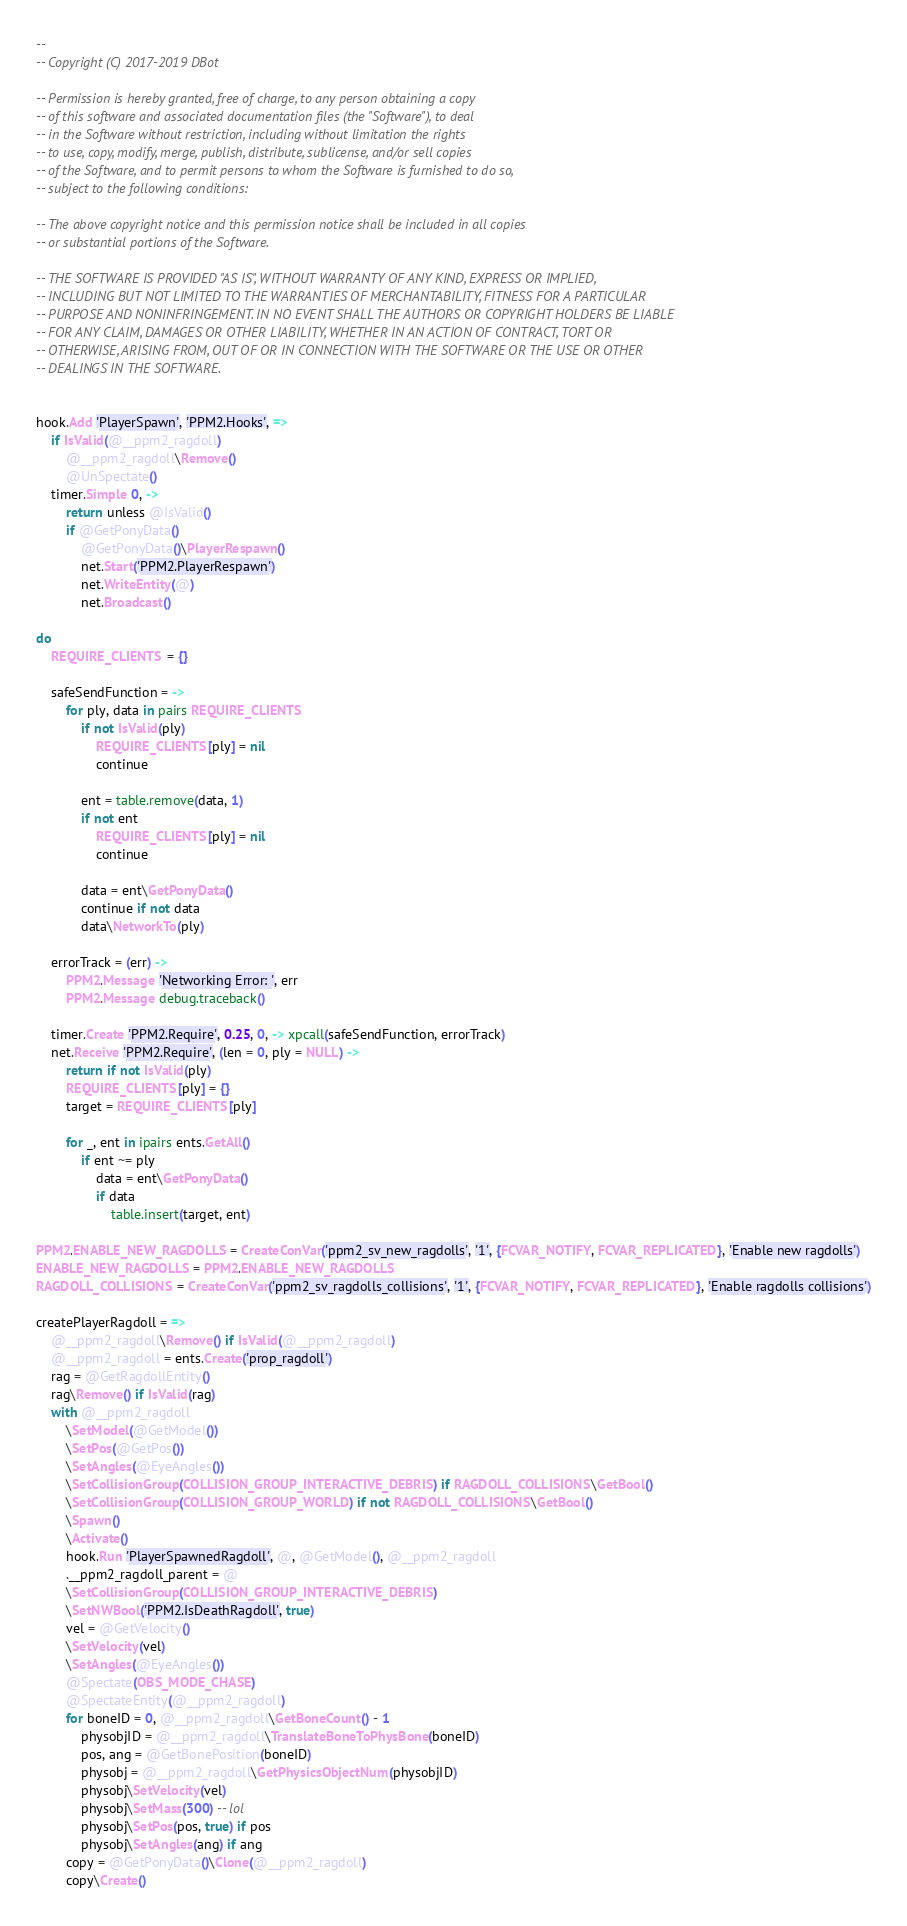<code> <loc_0><loc_0><loc_500><loc_500><_MoonScript_>
--
-- Copyright (C) 2017-2019 DBot

-- Permission is hereby granted, free of charge, to any person obtaining a copy
-- of this software and associated documentation files (the "Software"), to deal
-- in the Software without restriction, including without limitation the rights
-- to use, copy, modify, merge, publish, distribute, sublicense, and/or sell copies
-- of the Software, and to permit persons to whom the Software is furnished to do so,
-- subject to the following conditions:

-- The above copyright notice and this permission notice shall be included in all copies
-- or substantial portions of the Software.

-- THE SOFTWARE IS PROVIDED "AS IS", WITHOUT WARRANTY OF ANY KIND, EXPRESS OR IMPLIED,
-- INCLUDING BUT NOT LIMITED TO THE WARRANTIES OF MERCHANTABILITY, FITNESS FOR A PARTICULAR
-- PURPOSE AND NONINFRINGEMENT. IN NO EVENT SHALL THE AUTHORS OR COPYRIGHT HOLDERS BE LIABLE
-- FOR ANY CLAIM, DAMAGES OR OTHER LIABILITY, WHETHER IN AN ACTION OF CONTRACT, TORT OR
-- OTHERWISE, ARISING FROM, OUT OF OR IN CONNECTION WITH THE SOFTWARE OR THE USE OR OTHER
-- DEALINGS IN THE SOFTWARE.


hook.Add 'PlayerSpawn', 'PPM2.Hooks', =>
	if IsValid(@__ppm2_ragdoll)
		@__ppm2_ragdoll\Remove()
		@UnSpectate()
	timer.Simple 0, ->
		return unless @IsValid()
		if @GetPonyData()
			@GetPonyData()\PlayerRespawn()
			net.Start('PPM2.PlayerRespawn')
			net.WriteEntity(@)
			net.Broadcast()

do
	REQUIRE_CLIENTS = {}

	safeSendFunction = ->
		for ply, data in pairs REQUIRE_CLIENTS
			if not IsValid(ply)
				REQUIRE_CLIENTS[ply] = nil
				continue

			ent = table.remove(data, 1)
			if not ent
				REQUIRE_CLIENTS[ply] = nil
				continue

			data = ent\GetPonyData()
			continue if not data
			data\NetworkTo(ply)

	errorTrack = (err) ->
		PPM2.Message 'Networking Error: ', err
		PPM2.Message debug.traceback()

	timer.Create 'PPM2.Require', 0.25, 0, -> xpcall(safeSendFunction, errorTrack)
	net.Receive 'PPM2.Require', (len = 0, ply = NULL) ->
		return if not IsValid(ply)
		REQUIRE_CLIENTS[ply] = {}
		target = REQUIRE_CLIENTS[ply]

		for _, ent in ipairs ents.GetAll()
			if ent ~= ply
				data = ent\GetPonyData()
				if data
					table.insert(target, ent)

PPM2.ENABLE_NEW_RAGDOLLS = CreateConVar('ppm2_sv_new_ragdolls', '1', {FCVAR_NOTIFY, FCVAR_REPLICATED}, 'Enable new ragdolls')
ENABLE_NEW_RAGDOLLS = PPM2.ENABLE_NEW_RAGDOLLS
RAGDOLL_COLLISIONS = CreateConVar('ppm2_sv_ragdolls_collisions', '1', {FCVAR_NOTIFY, FCVAR_REPLICATED}, 'Enable ragdolls collisions')

createPlayerRagdoll = =>
	@__ppm2_ragdoll\Remove() if IsValid(@__ppm2_ragdoll)
	@__ppm2_ragdoll = ents.Create('prop_ragdoll')
	rag = @GetRagdollEntity()
	rag\Remove() if IsValid(rag)
	with @__ppm2_ragdoll
		\SetModel(@GetModel())
		\SetPos(@GetPos())
		\SetAngles(@EyeAngles())
		\SetCollisionGroup(COLLISION_GROUP_INTERACTIVE_DEBRIS) if RAGDOLL_COLLISIONS\GetBool()
		\SetCollisionGroup(COLLISION_GROUP_WORLD) if not RAGDOLL_COLLISIONS\GetBool()
		\Spawn()
		\Activate()
		hook.Run 'PlayerSpawnedRagdoll', @, @GetModel(), @__ppm2_ragdoll
		.__ppm2_ragdoll_parent = @
		\SetCollisionGroup(COLLISION_GROUP_INTERACTIVE_DEBRIS)
		\SetNWBool('PPM2.IsDeathRagdoll', true)
		vel = @GetVelocity()
		\SetVelocity(vel)
		\SetAngles(@EyeAngles())
		@Spectate(OBS_MODE_CHASE)
		@SpectateEntity(@__ppm2_ragdoll)
		for boneID = 0, @__ppm2_ragdoll\GetBoneCount() - 1
			physobjID = @__ppm2_ragdoll\TranslateBoneToPhysBone(boneID)
			pos, ang = @GetBonePosition(boneID)
			physobj = @__ppm2_ragdoll\GetPhysicsObjectNum(physobjID)
			physobj\SetVelocity(vel)
			physobj\SetMass(300) -- lol
			physobj\SetPos(pos, true) if pos
			physobj\SetAngles(ang) if ang
		copy = @GetPonyData()\Clone(@__ppm2_ragdoll)
		copy\Create()
</code> 